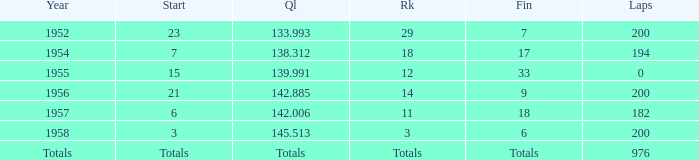What place did Jimmy Reece start from when he ranked 12? 15.0. 